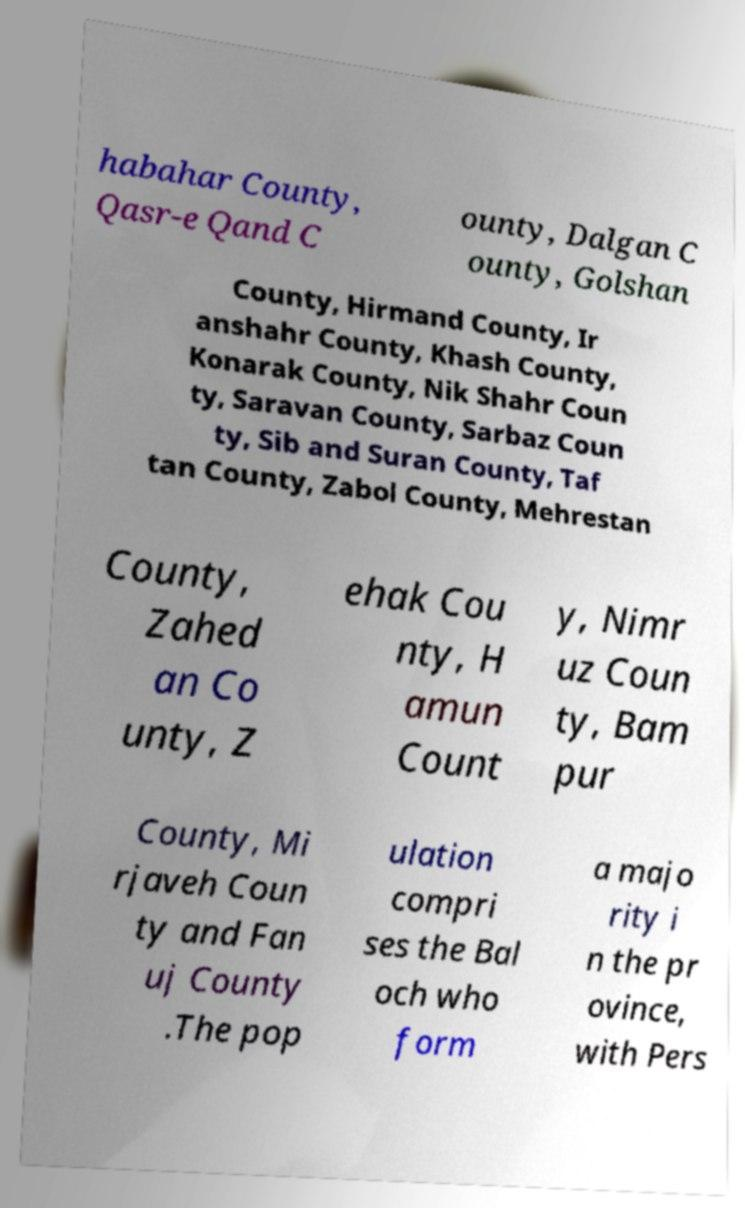Could you extract and type out the text from this image? habahar County, Qasr-e Qand C ounty, Dalgan C ounty, Golshan County, Hirmand County, Ir anshahr County, Khash County, Konarak County, Nik Shahr Coun ty, Saravan County, Sarbaz Coun ty, Sib and Suran County, Taf tan County, Zabol County, Mehrestan County, Zahed an Co unty, Z ehak Cou nty, H amun Count y, Nimr uz Coun ty, Bam pur County, Mi rjaveh Coun ty and Fan uj County .The pop ulation compri ses the Bal och who form a majo rity i n the pr ovince, with Pers 